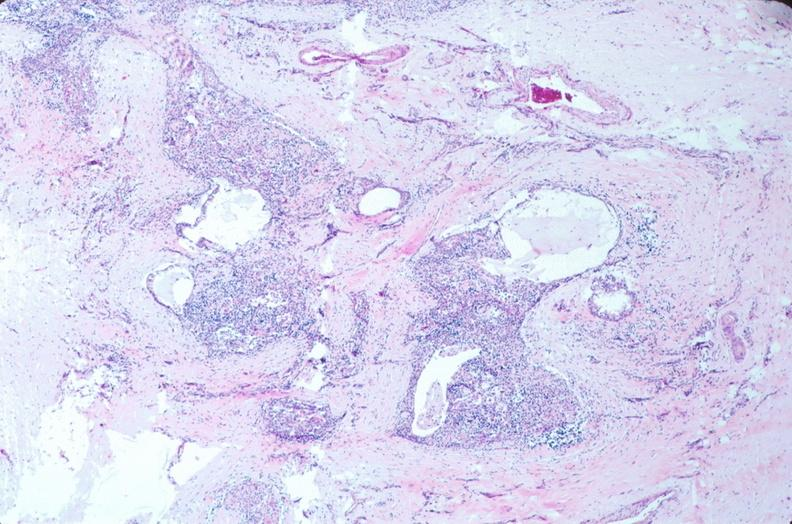what is present?
Answer the question using a single word or phrase. Embryo-fetus 